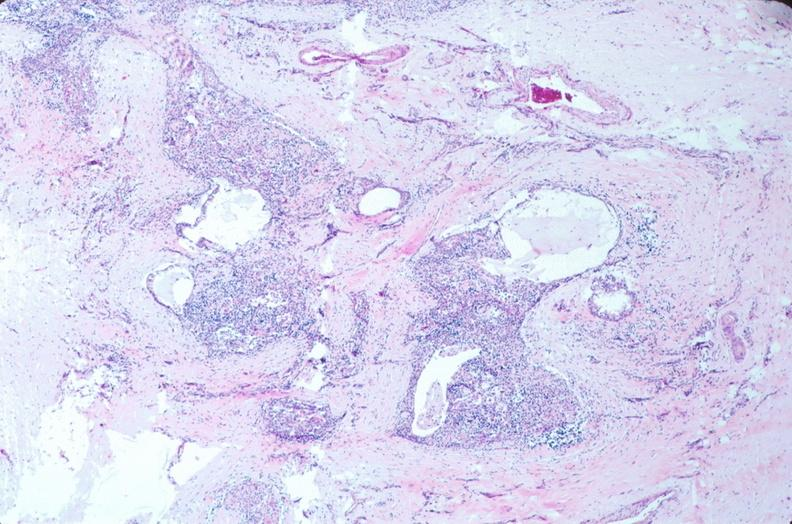what is present?
Answer the question using a single word or phrase. Embryo-fetus 